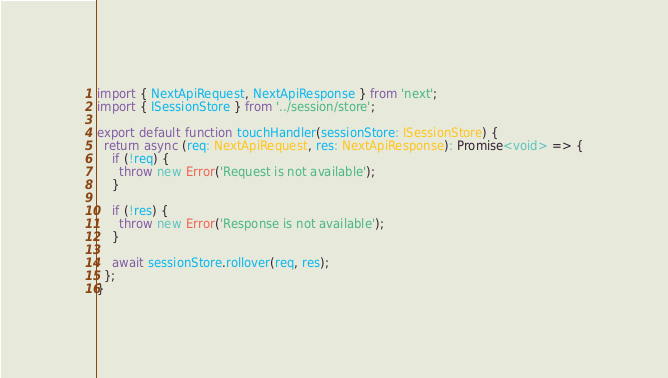Convert code to text. <code><loc_0><loc_0><loc_500><loc_500><_TypeScript_>import { NextApiRequest, NextApiResponse } from 'next';
import { ISessionStore } from '../session/store';

export default function touchHandler(sessionStore: ISessionStore) {
  return async (req: NextApiRequest, res: NextApiResponse): Promise<void> => {
    if (!req) {
      throw new Error('Request is not available');
    }

    if (!res) {
      throw new Error('Response is not available');
    }

    await sessionStore.rollover(req, res);
  };
}
</code> 